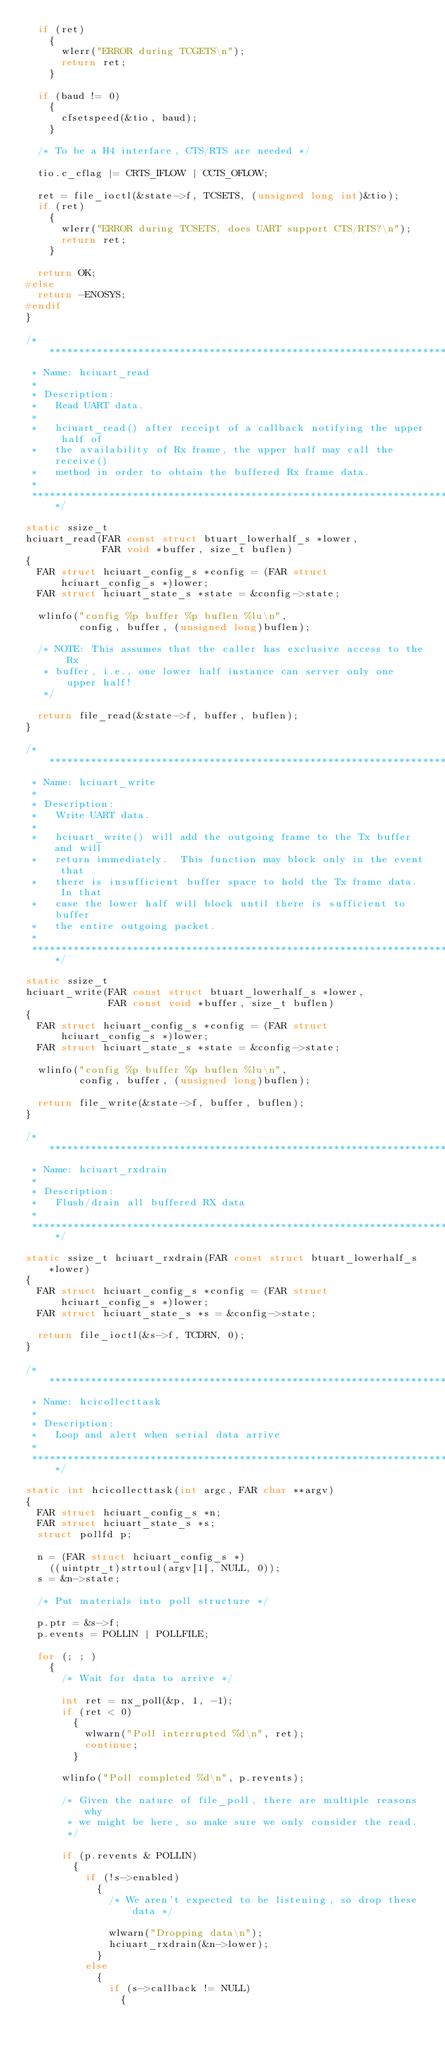Convert code to text. <code><loc_0><loc_0><loc_500><loc_500><_C_>  if (ret)
    {
      wlerr("ERROR during TCGETS\n");
      return ret;
    }

  if (baud != 0)
    {
      cfsetspeed(&tio, baud);
    }

  /* To be a H4 interface, CTS/RTS are needed */

  tio.c_cflag |= CRTS_IFLOW | CCTS_OFLOW;

  ret = file_ioctl(&state->f, TCSETS, (unsigned long int)&tio);
  if (ret)
    {
      wlerr("ERROR during TCSETS, does UART support CTS/RTS?\n");
      return ret;
    }

  return OK;
#else
  return -ENOSYS;
#endif
}

/****************************************************************************
 * Name: hciuart_read
 *
 * Description:
 *   Read UART data.
 *
 *   hciuart_read() after receipt of a callback notifying the upper half of
 *   the availability of Rx frame, the upper half may call the receive()
 *   method in order to obtain the buffered Rx frame data.
 *
 ****************************************************************************/

static ssize_t
hciuart_read(FAR const struct btuart_lowerhalf_s *lower,
             FAR void *buffer, size_t buflen)
{
  FAR struct hciuart_config_s *config = (FAR struct hciuart_config_s *)lower;
  FAR struct hciuart_state_s *state = &config->state;

  wlinfo("config %p buffer %p buflen %lu\n",
         config, buffer, (unsigned long)buflen);

  /* NOTE: This assumes that the caller has exclusive access to the Rx
   * buffer, i.e., one lower half instance can server only one upper half!
   */

  return file_read(&state->f, buffer, buflen);
}

/****************************************************************************
 * Name: hciuart_write
 *
 * Description:
 *   Write UART data.
 *
 *   hciuart_write() will add the outgoing frame to the Tx buffer and will
 *   return immediately.  This function may block only in the event that
 *   there is insufficient buffer space to hold the Tx frame data.  In that
 *   case the lower half will block until there is sufficient to buffer
 *   the entire outgoing packet.
 *
 ****************************************************************************/

static ssize_t
hciuart_write(FAR const struct btuart_lowerhalf_s *lower,
              FAR const void *buffer, size_t buflen)
{
  FAR struct hciuart_config_s *config = (FAR struct hciuart_config_s *)lower;
  FAR struct hciuart_state_s *state = &config->state;

  wlinfo("config %p buffer %p buflen %lu\n",
         config, buffer, (unsigned long)buflen);

  return file_write(&state->f, buffer, buflen);
}

/****************************************************************************
 * Name: hciuart_rxdrain
 *
 * Description:
 *   Flush/drain all buffered RX data
 *
 ****************************************************************************/

static ssize_t hciuart_rxdrain(FAR const struct btuart_lowerhalf_s *lower)
{
  FAR struct hciuart_config_s *config = (FAR struct hciuart_config_s *)lower;
  FAR struct hciuart_state_s *s = &config->state;

  return file_ioctl(&s->f, TCDRN, 0);
}

/****************************************************************************
 * Name: hcicollecttask
 *
 * Description:
 *   Loop and alert when serial data arrive
 *
 ****************************************************************************/

static int hcicollecttask(int argc, FAR char **argv)
{
  FAR struct hciuart_config_s *n;
  FAR struct hciuart_state_s *s;
  struct pollfd p;

  n = (FAR struct hciuart_config_s *)
    ((uintptr_t)strtoul(argv[1], NULL, 0));
  s = &n->state;

  /* Put materials into poll structure */

  p.ptr = &s->f;
  p.events = POLLIN | POLLFILE;

  for (; ; )
    {
      /* Wait for data to arrive */

      int ret = nx_poll(&p, 1, -1);
      if (ret < 0)
        {
          wlwarn("Poll interrupted %d\n", ret);
          continue;
        }

      wlinfo("Poll completed %d\n", p.revents);

      /* Given the nature of file_poll, there are multiple reasons why
       * we might be here, so make sure we only consider the read.
       */

      if (p.revents & POLLIN)
        {
          if (!s->enabled)
            {
              /* We aren't expected to be listening, so drop these data */

              wlwarn("Dropping data\n");
              hciuart_rxdrain(&n->lower);
            }
          else
            {
              if (s->callback != NULL)
                {</code> 